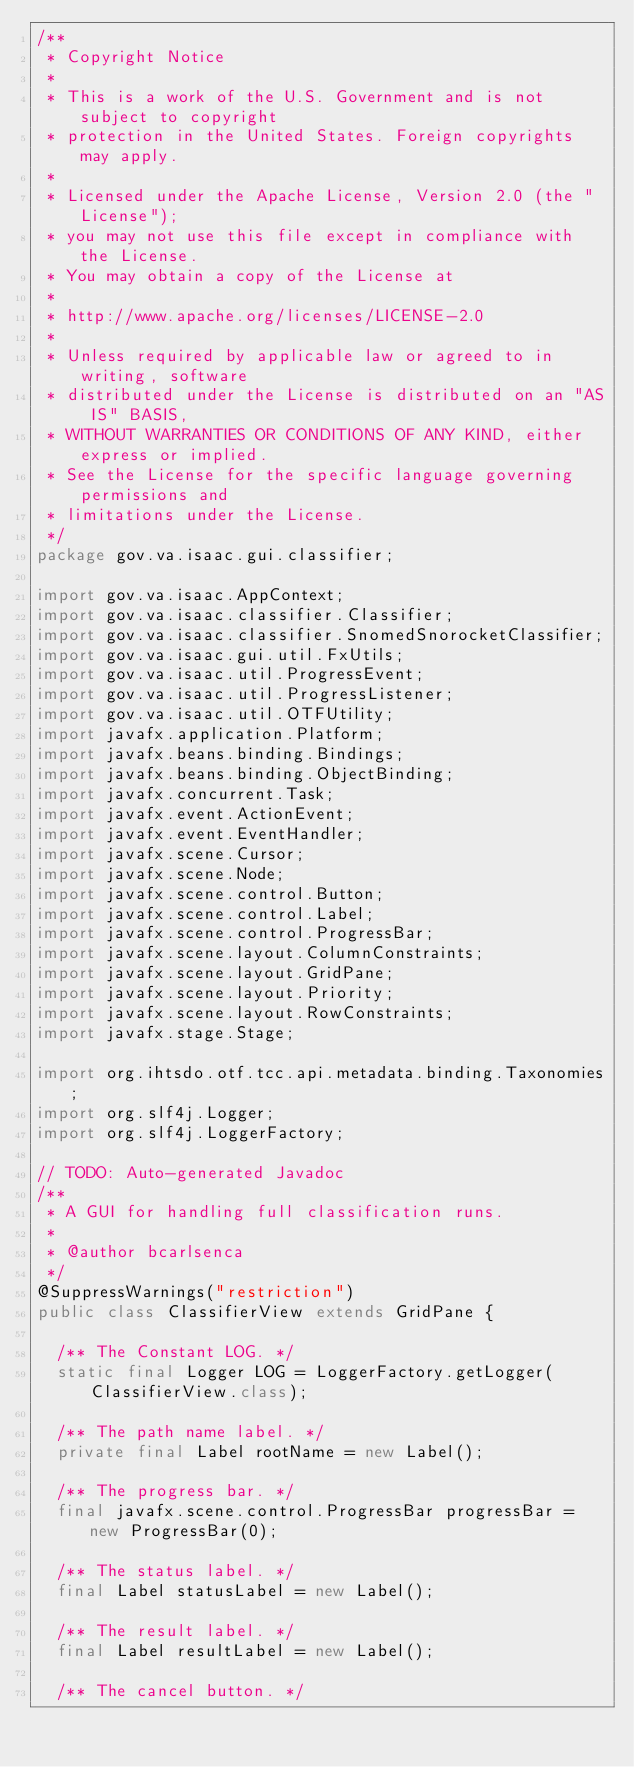<code> <loc_0><loc_0><loc_500><loc_500><_Java_>/**
 * Copyright Notice
 *
 * This is a work of the U.S. Government and is not subject to copyright
 * protection in the United States. Foreign copyrights may apply.
 *
 * Licensed under the Apache License, Version 2.0 (the "License");
 * you may not use this file except in compliance with the License.
 * You may obtain a copy of the License at
 *
 * http://www.apache.org/licenses/LICENSE-2.0
 *
 * Unless required by applicable law or agreed to in writing, software
 * distributed under the License is distributed on an "AS IS" BASIS,
 * WITHOUT WARRANTIES OR CONDITIONS OF ANY KIND, either express or implied.
 * See the License for the specific language governing permissions and
 * limitations under the License.
 */
package gov.va.isaac.gui.classifier;

import gov.va.isaac.AppContext;
import gov.va.isaac.classifier.Classifier;
import gov.va.isaac.classifier.SnomedSnorocketClassifier;
import gov.va.isaac.gui.util.FxUtils;
import gov.va.isaac.util.ProgressEvent;
import gov.va.isaac.util.ProgressListener;
import gov.va.isaac.util.OTFUtility;
import javafx.application.Platform;
import javafx.beans.binding.Bindings;
import javafx.beans.binding.ObjectBinding;
import javafx.concurrent.Task;
import javafx.event.ActionEvent;
import javafx.event.EventHandler;
import javafx.scene.Cursor;
import javafx.scene.Node;
import javafx.scene.control.Button;
import javafx.scene.control.Label;
import javafx.scene.control.ProgressBar;
import javafx.scene.layout.ColumnConstraints;
import javafx.scene.layout.GridPane;
import javafx.scene.layout.Priority;
import javafx.scene.layout.RowConstraints;
import javafx.stage.Stage;

import org.ihtsdo.otf.tcc.api.metadata.binding.Taxonomies;
import org.slf4j.Logger;
import org.slf4j.LoggerFactory;

// TODO: Auto-generated Javadoc
/**
 * A GUI for handling full classification runs.
 *
 * @author bcarlsenca
 */
@SuppressWarnings("restriction")
public class ClassifierView extends GridPane {

  /** The Constant LOG. */
  static final Logger LOG = LoggerFactory.getLogger(ClassifierView.class);

  /** The path name label. */
  private final Label rootName = new Label();

  /** The progress bar. */
  final javafx.scene.control.ProgressBar progressBar = new ProgressBar(0);

  /** The status label. */
  final Label statusLabel = new Label();

  /** The result label. */
  final Label resultLabel = new Label();

  /** The cancel button. */</code> 